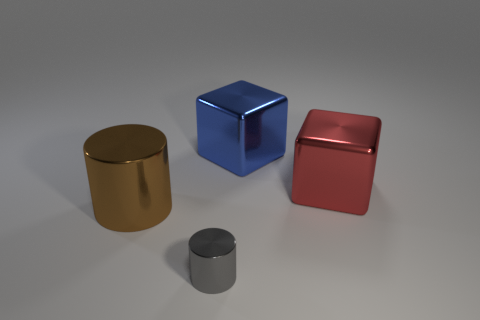In what kind of setting could you find these objects? These objects could be found in a variety of settings, from a modern art exhibit for their simplistic and reflective qualities to a 3D modeling studio as part of a test render for materials and lighting effects. 